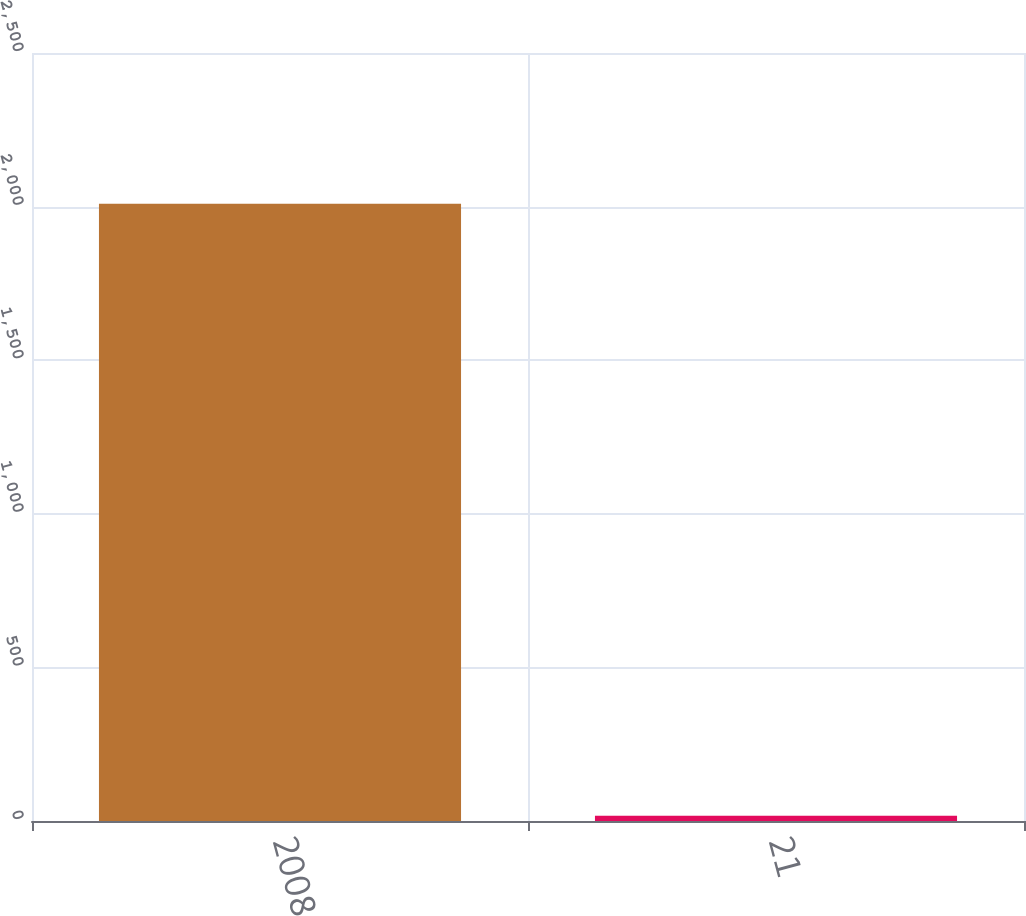Convert chart. <chart><loc_0><loc_0><loc_500><loc_500><bar_chart><fcel>2008<fcel>21<nl><fcel>2009<fcel>17<nl></chart> 